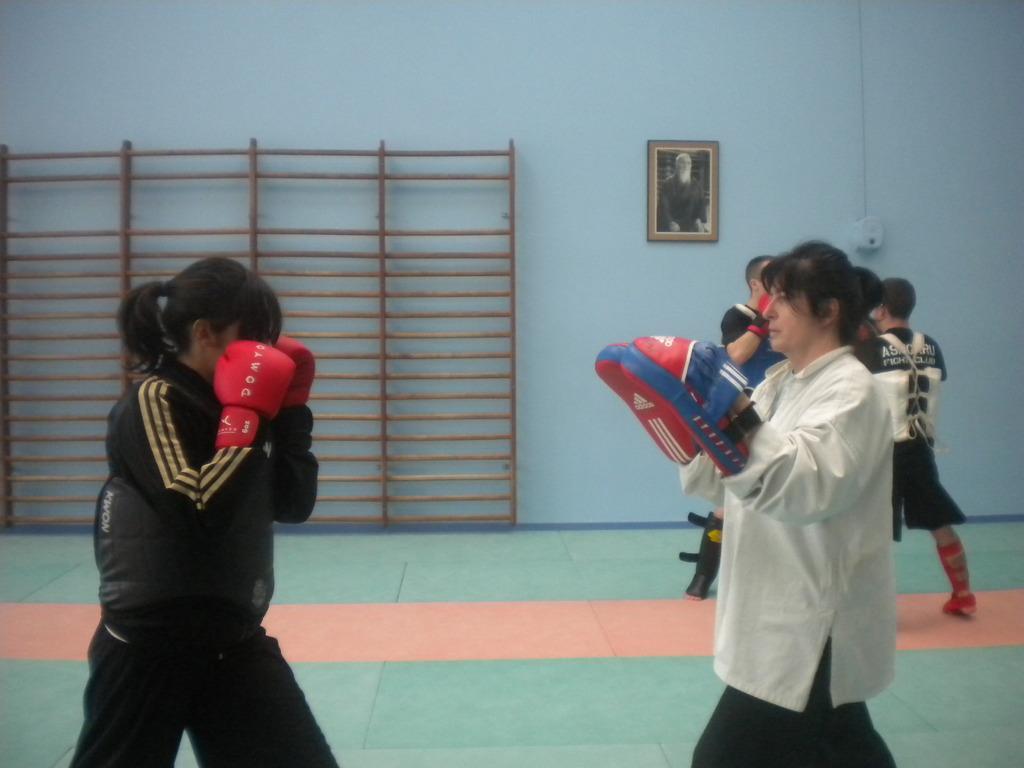Describe this image in one or two sentences. In this image, we can see two women wearing gloves. In the background, we can see an object and photo frame on the wall. On the right side of the image, we can see people on the floor. 